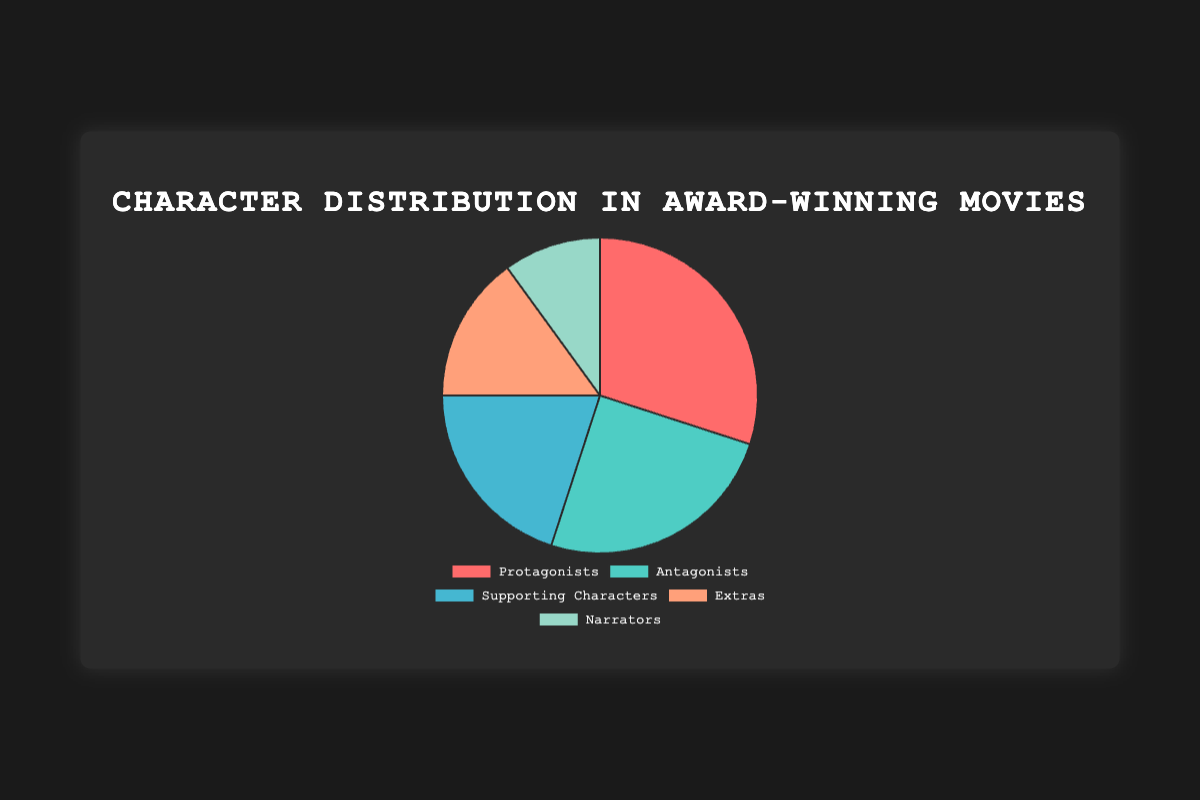What's the percentage of Protagonists in the figure? The pie chart shows that Protagonists make up a 30% share of the total characters depicted. This is derived directly from the specific section labeled "Protagonists" in the pie chart.
Answer: 30% What is the difference in percentage between Protagonists and Narrators? The percentage for Protagonists is 30% and for Narrators is 10%. The difference is calculated by subtracting the percentage of Narrators from that of Protagonists: 30% - 10% = 20%.
Answer: 20% Which character type occupies the largest segment in the pie chart? By visually comparing the segments, the Protagonists segment appears the largest at 30%, making Protagonists the character type with the largest representation in the chart.
Answer: Protagonists How do the percentages of Antagonists and Supporting Characters compare to each other? The chart shows that Antagonists make up 25%, and Supporting Characters make up 20%. Comparing these directly, Antagonists have a 5% higher representation than Supporting Characters.
Answer: Antagonists have a higher percentage What is the combined percentage of Supporting Characters and Extras? The pie chart shows Supporting Characters at 20% and Extras at 15%. Adding these together gives: 20% + 15% = 35%.
Answer: 35% Which character type is represented by the color green? By looking at the color coding in the pie chart, the green segment corresponds to Antagonists.
Answer: Antagonists How much larger is the percentage of Protagonists compared to Extras? From the chart, Protagonists are at 30% and Extras at 15%. The difference is calculated as 30% - 15% = 15%.
Answer: 15% larger What are the two least represented character types in the chart? The pie chart shows that the least represented character types are Extras at 15% and Narrators at 10%.
Answer: Extras and Narrators If you were to combine the percentages of Antagonists and Narrators, what would be their combined share? The percentage for Antagonists is 25% and Narrators is 10%. Adding them together gives: 25% + 10% = 35%.
Answer: 35% Which character type is represented by a segment that is visually smaller than the Antagonists but larger than the Narrators? Supporting Characters are represented by a 20% segment which is larger than Narrators at 10% and smaller than Antagonists at 25% according to the pie chart.
Answer: Supporting Characters 